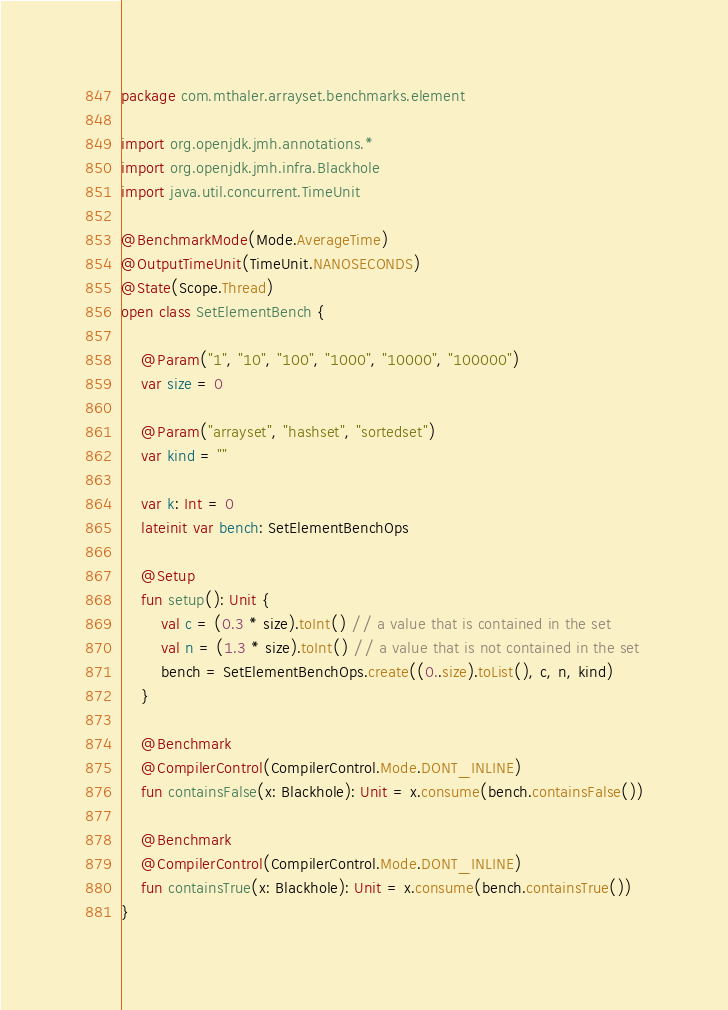<code> <loc_0><loc_0><loc_500><loc_500><_Kotlin_>package com.mthaler.arrayset.benchmarks.element

import org.openjdk.jmh.annotations.*
import org.openjdk.jmh.infra.Blackhole
import java.util.concurrent.TimeUnit

@BenchmarkMode(Mode.AverageTime)
@OutputTimeUnit(TimeUnit.NANOSECONDS)
@State(Scope.Thread)
open class SetElementBench {

    @Param("1", "10", "100", "1000", "10000", "100000")
    var size = 0

    @Param("arrayset", "hashset", "sortedset")
    var kind = ""

    var k: Int = 0
    lateinit var bench: SetElementBenchOps

    @Setup
    fun setup(): Unit {
        val c = (0.3 * size).toInt() // a value that is contained in the set
        val n = (1.3 * size).toInt() // a value that is not contained in the set
        bench = SetElementBenchOps.create((0..size).toList(), c, n, kind)
    }

    @Benchmark
    @CompilerControl(CompilerControl.Mode.DONT_INLINE)
    fun containsFalse(x: Blackhole): Unit = x.consume(bench.containsFalse())

    @Benchmark
    @CompilerControl(CompilerControl.Mode.DONT_INLINE)
    fun containsTrue(x: Blackhole): Unit = x.consume(bench.containsTrue())
}</code> 